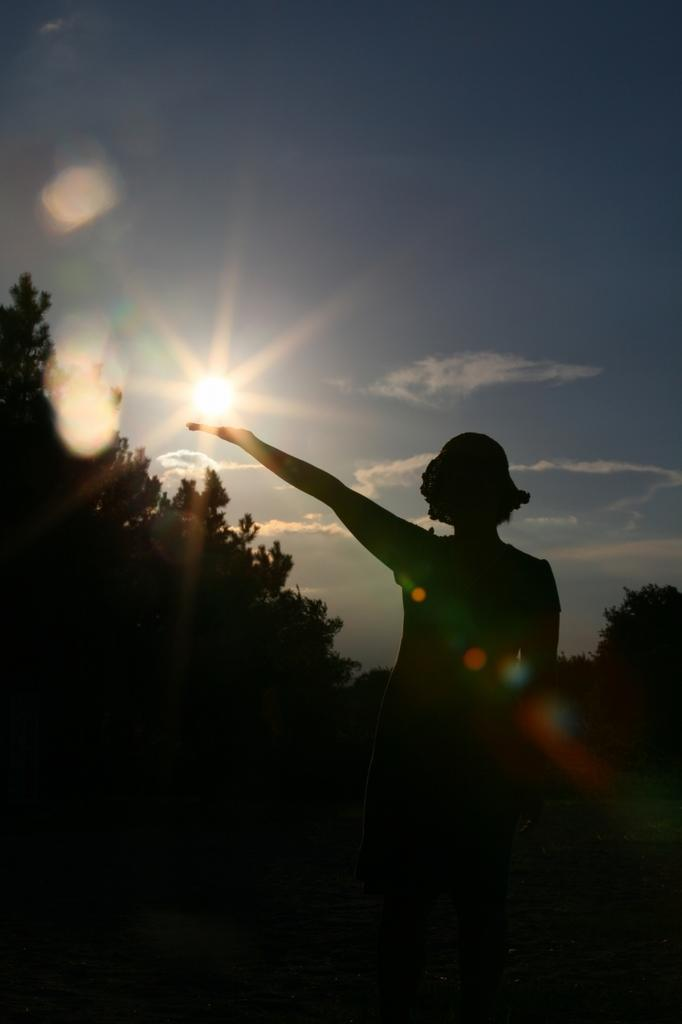What is the main subject of the image? There is a woman standing in the image. What can be seen in the background of the image? There are trees in the background of the image. What is the condition of the sky in the image? The sun is visible in the sky in the image. Can you tell me how many zebras are standing next to the woman in the image? There are no zebras present in the image; it only features a woman standing. What type of tramp is visible in the image? There is: There is no tramp present in the image. 